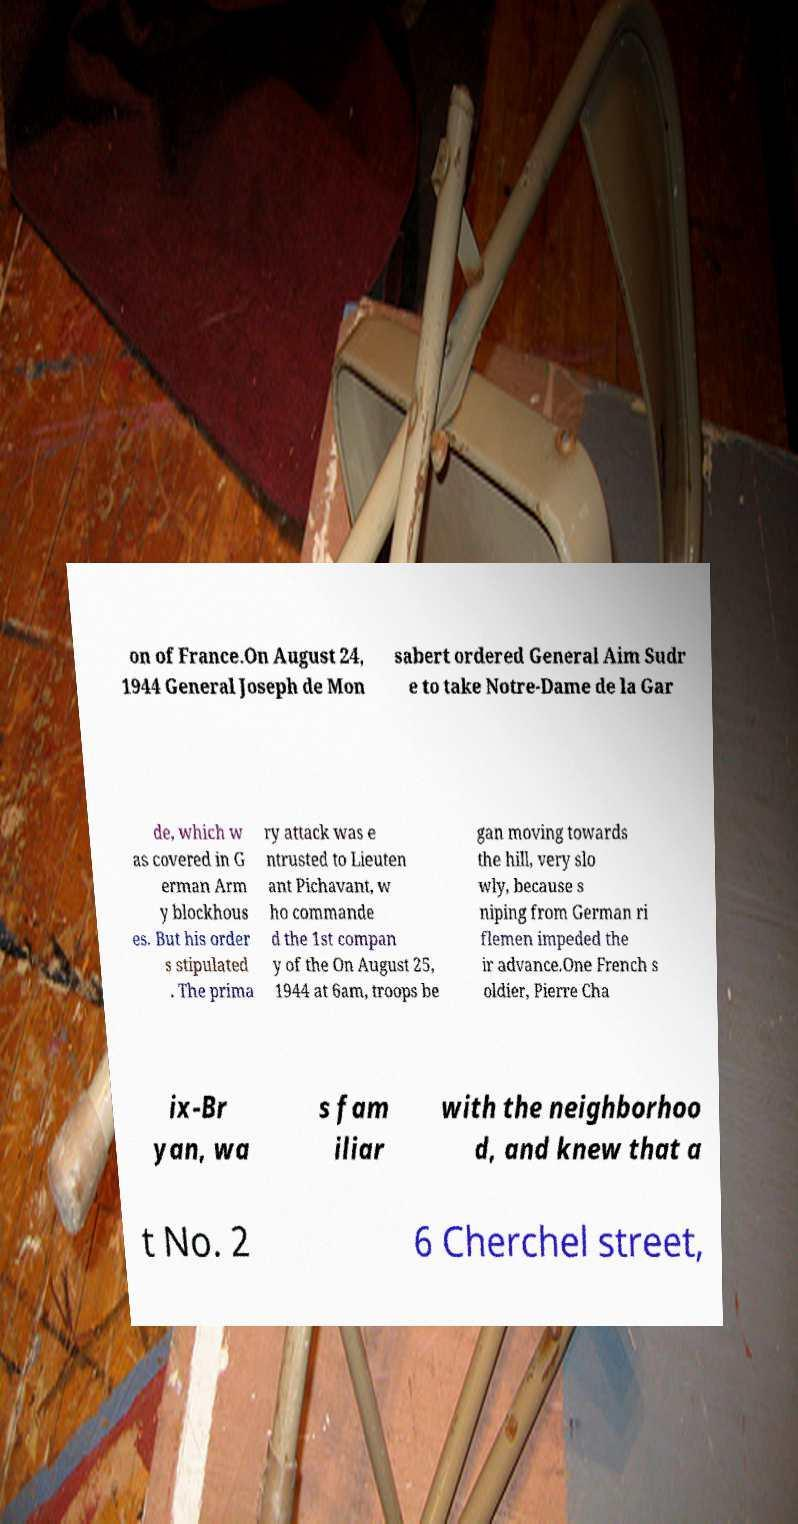For documentation purposes, I need the text within this image transcribed. Could you provide that? on of France.On August 24, 1944 General Joseph de Mon sabert ordered General Aim Sudr e to take Notre-Dame de la Gar de, which w as covered in G erman Arm y blockhous es. But his order s stipulated . The prima ry attack was e ntrusted to Lieuten ant Pichavant, w ho commande d the 1st compan y of the On August 25, 1944 at 6am, troops be gan moving towards the hill, very slo wly, because s niping from German ri flemen impeded the ir advance.One French s oldier, Pierre Cha ix-Br yan, wa s fam iliar with the neighborhoo d, and knew that a t No. 2 6 Cherchel street, 